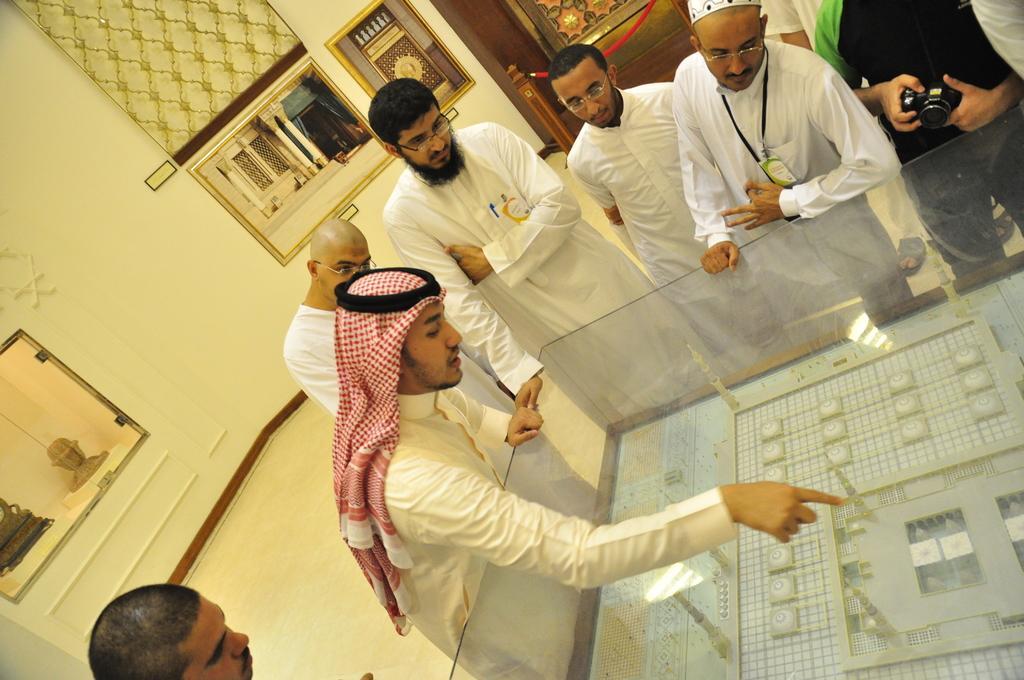In one or two sentences, can you explain what this image depicts? This image consists of few persons. In the front, we can see a building plan in the glass box. In the background, there is a wall. And there are some objects in the glasses. At the bottom, there is a floor. 